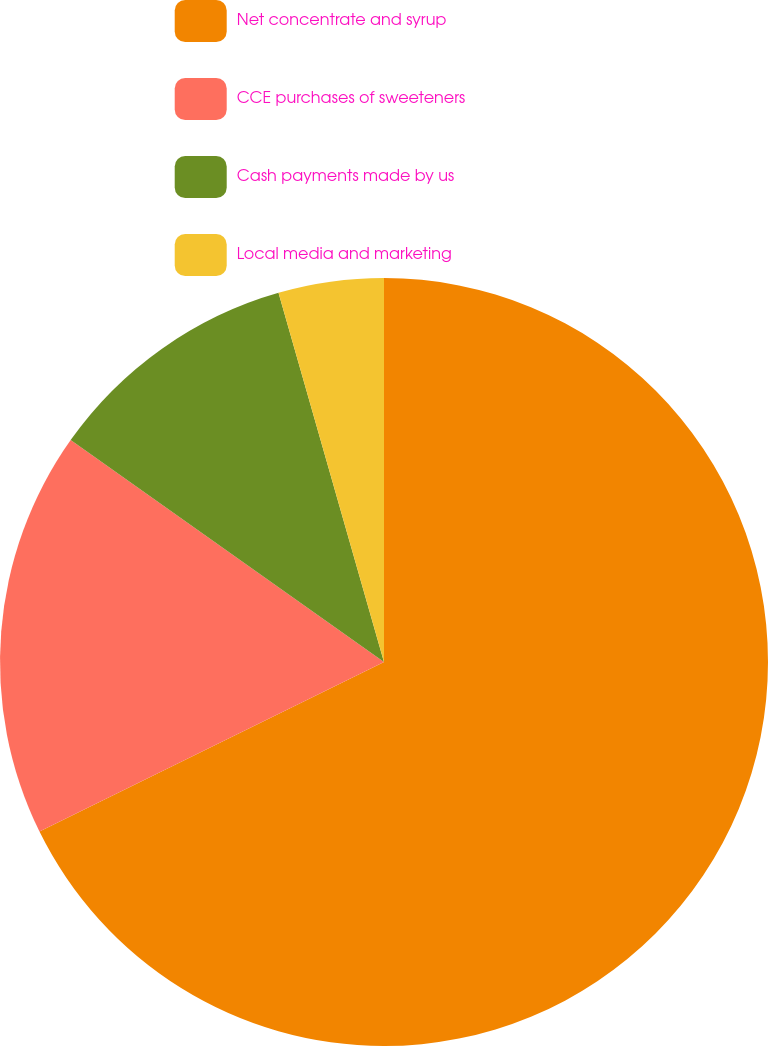<chart> <loc_0><loc_0><loc_500><loc_500><pie_chart><fcel>Net concentrate and syrup<fcel>CCE purchases of sweeteners<fcel>Cash payments made by us<fcel>Local media and marketing<nl><fcel>67.72%<fcel>17.09%<fcel>10.76%<fcel>4.43%<nl></chart> 